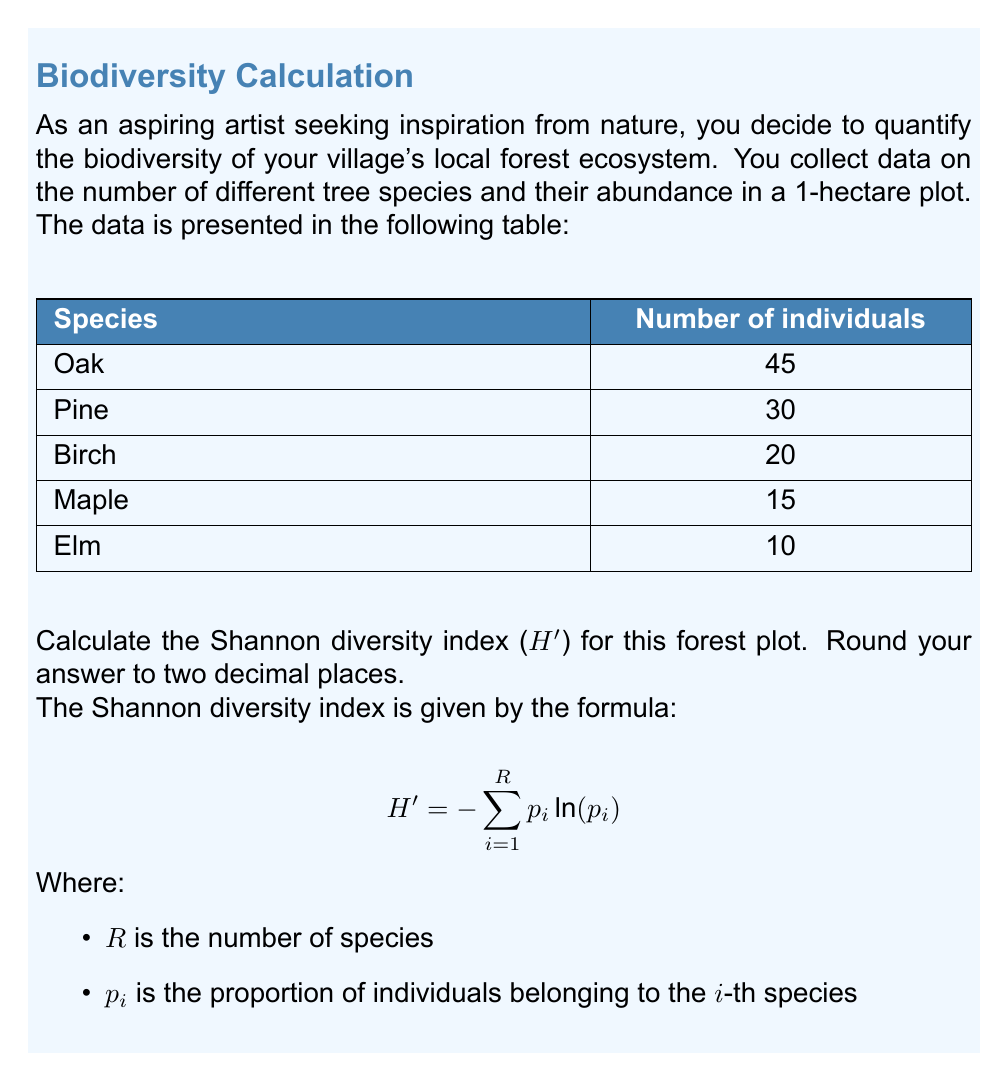Can you solve this math problem? To calculate the Shannon diversity index, we'll follow these steps:

1. Calculate the total number of individuals:
   $45 + 30 + 20 + 15 + 10 = 120$ total individuals

2. Calculate the proportion ($p_i$) for each species:
   Oak: $p_1 = 45/120 = 0.375$
   Pine: $p_2 = 30/120 = 0.25$
   Birch: $p_3 = 20/120 = 0.1667$
   Maple: $p_4 = 15/120 = 0.125$
   Elm: $p_5 = 10/120 = 0.0833$

3. Calculate $p_i \ln(p_i)$ for each species:
   Oak: $0.375 \ln(0.375) = -0.3677$
   Pine: $0.25 \ln(0.25) = -0.3466$
   Birch: $0.1667 \ln(0.1667) = -0.2987$
   Maple: $0.125 \ln(0.125) = -0.2599$
   Elm: $0.0833 \ln(0.0833) = -0.2060$

4. Sum the negative values:
   $H' = -(-0.3677 - 0.3466 - 0.2987 - 0.2599 - 0.2060)$
   $H' = 1.4789$

5. Round to two decimal places:
   $H' = 1.48$

The Shannon diversity index for this forest plot is 1.48.
Answer: 1.48 